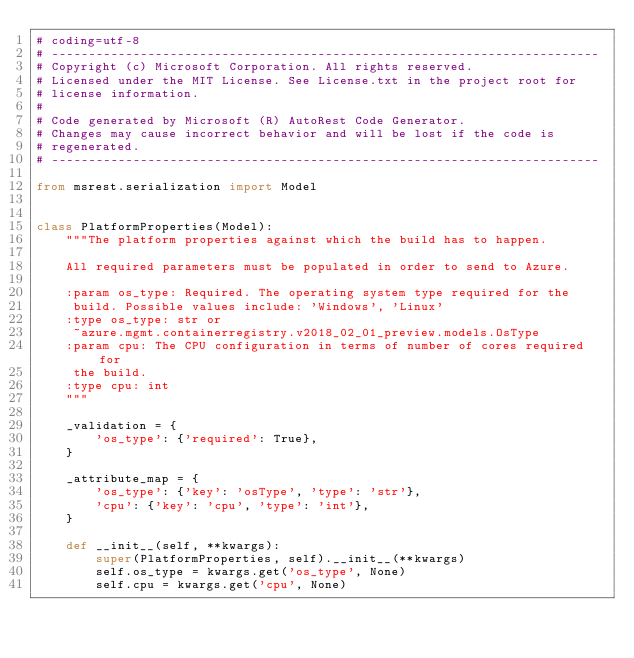Convert code to text. <code><loc_0><loc_0><loc_500><loc_500><_Python_># coding=utf-8
# --------------------------------------------------------------------------
# Copyright (c) Microsoft Corporation. All rights reserved.
# Licensed under the MIT License. See License.txt in the project root for
# license information.
#
# Code generated by Microsoft (R) AutoRest Code Generator.
# Changes may cause incorrect behavior and will be lost if the code is
# regenerated.
# --------------------------------------------------------------------------

from msrest.serialization import Model


class PlatformProperties(Model):
    """The platform properties against which the build has to happen.

    All required parameters must be populated in order to send to Azure.

    :param os_type: Required. The operating system type required for the
     build. Possible values include: 'Windows', 'Linux'
    :type os_type: str or
     ~azure.mgmt.containerregistry.v2018_02_01_preview.models.OsType
    :param cpu: The CPU configuration in terms of number of cores required for
     the build.
    :type cpu: int
    """

    _validation = {
        'os_type': {'required': True},
    }

    _attribute_map = {
        'os_type': {'key': 'osType', 'type': 'str'},
        'cpu': {'key': 'cpu', 'type': 'int'},
    }

    def __init__(self, **kwargs):
        super(PlatformProperties, self).__init__(**kwargs)
        self.os_type = kwargs.get('os_type', None)
        self.cpu = kwargs.get('cpu', None)
</code> 